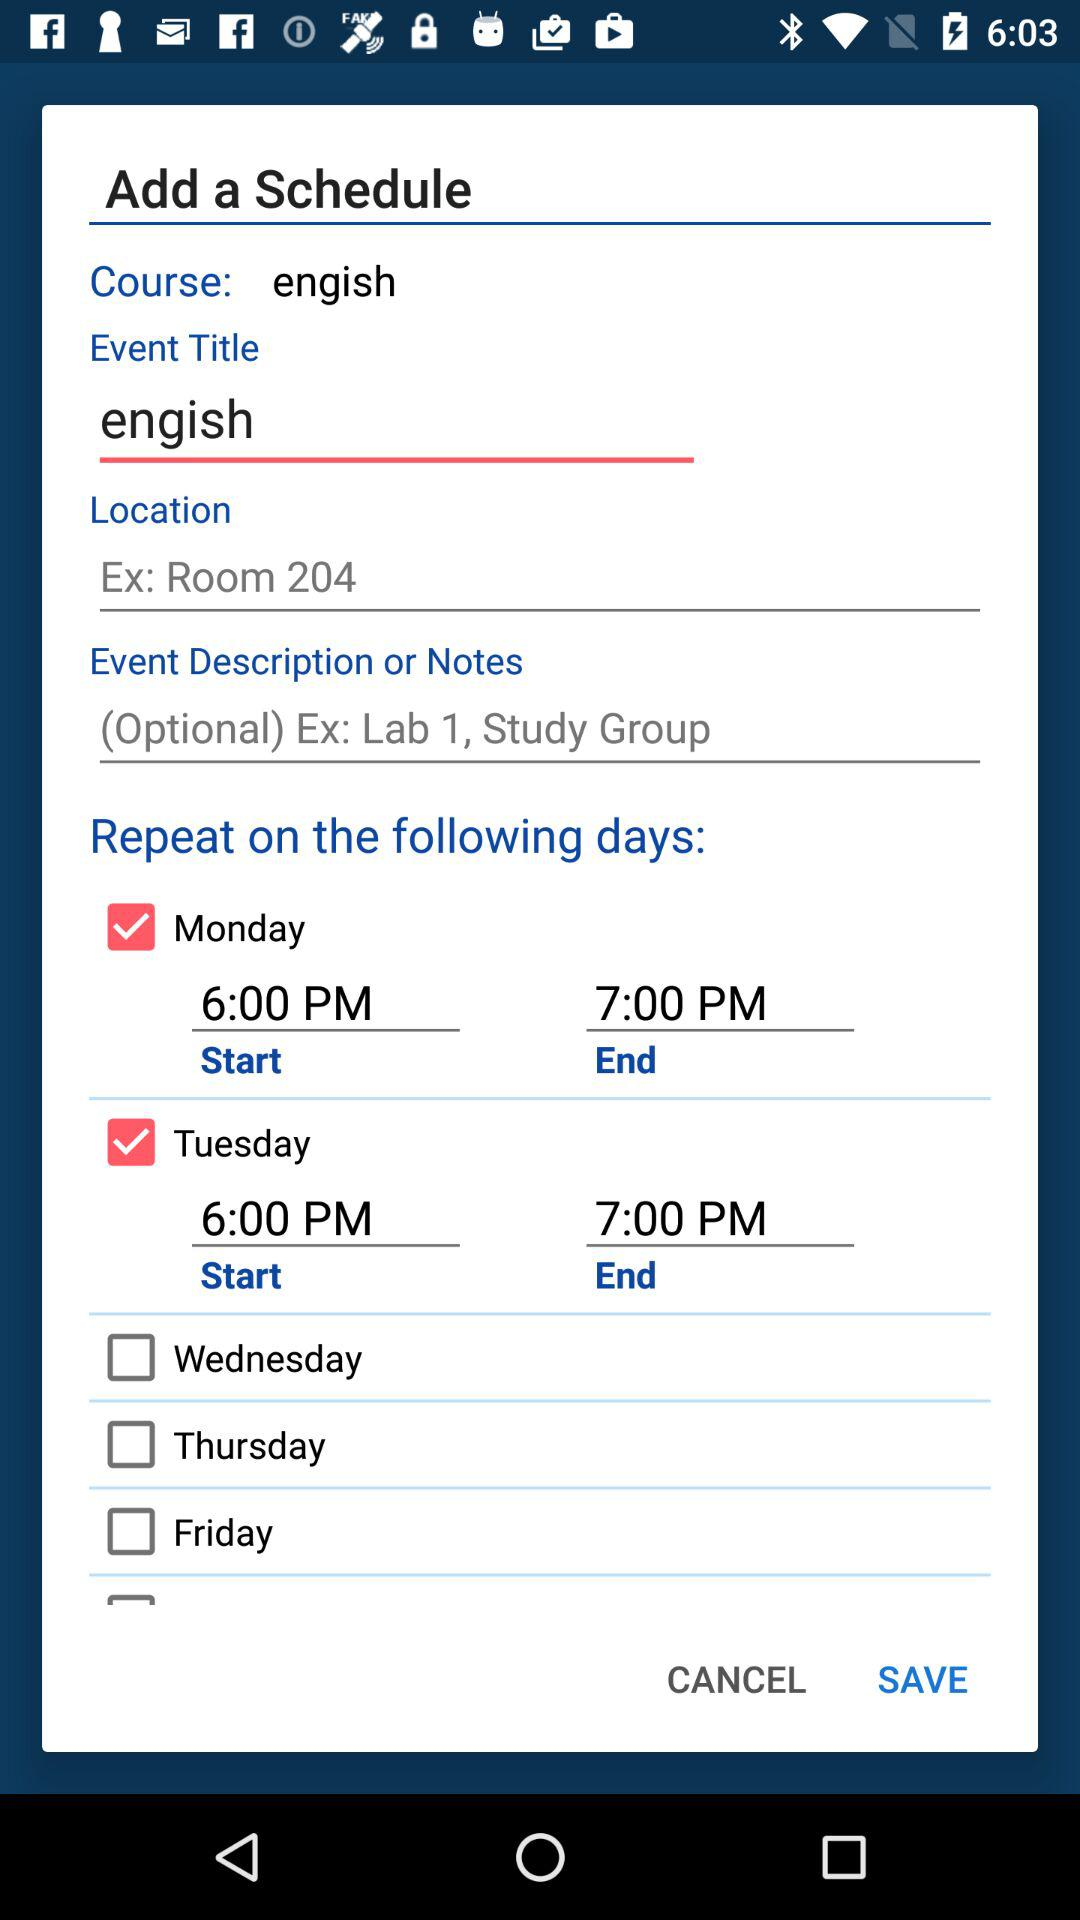What is the status of "Monday"? The status is "on". 